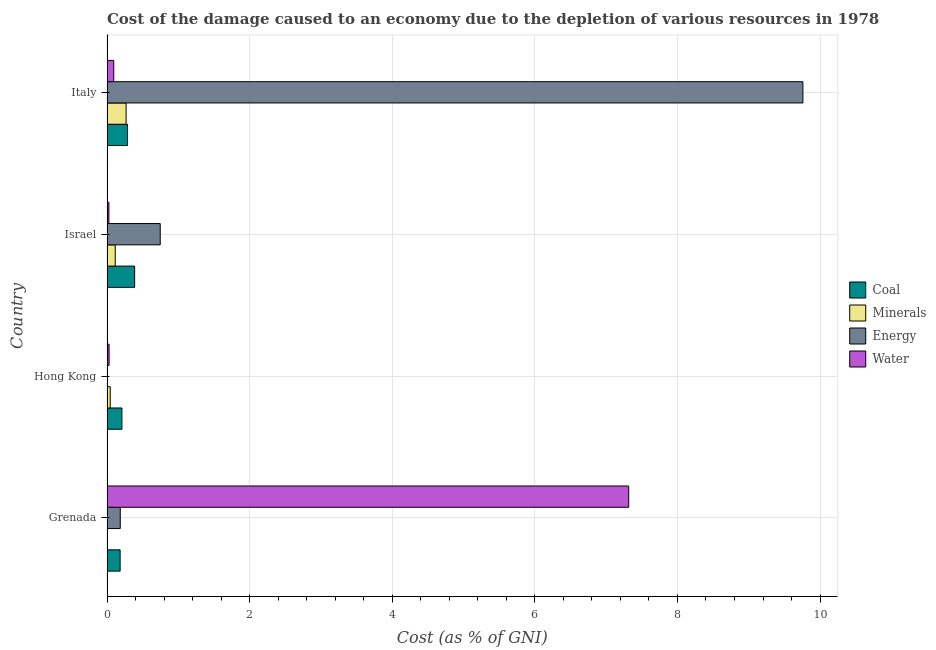Are the number of bars on each tick of the Y-axis equal?
Offer a very short reply. Yes. How many bars are there on the 1st tick from the bottom?
Provide a short and direct response. 4. What is the label of the 3rd group of bars from the top?
Make the answer very short. Hong Kong. What is the cost of damage due to depletion of energy in Israel?
Your response must be concise. 0.75. Across all countries, what is the maximum cost of damage due to depletion of water?
Ensure brevity in your answer.  7.32. Across all countries, what is the minimum cost of damage due to depletion of coal?
Your response must be concise. 0.18. In which country was the cost of damage due to depletion of water maximum?
Your answer should be compact. Grenada. What is the total cost of damage due to depletion of water in the graph?
Ensure brevity in your answer.  7.47. What is the difference between the cost of damage due to depletion of coal in Grenada and that in Italy?
Keep it short and to the point. -0.1. What is the difference between the cost of damage due to depletion of energy in Hong Kong and the cost of damage due to depletion of water in Israel?
Make the answer very short. -0.02. What is the average cost of damage due to depletion of coal per country?
Keep it short and to the point. 0.27. What is the difference between the cost of damage due to depletion of water and cost of damage due to depletion of energy in Israel?
Your answer should be compact. -0.72. In how many countries, is the cost of damage due to depletion of coal greater than 8 %?
Your answer should be very brief. 0. What is the ratio of the cost of damage due to depletion of coal in Hong Kong to that in Israel?
Give a very brief answer. 0.54. Is the difference between the cost of damage due to depletion of energy in Grenada and Hong Kong greater than the difference between the cost of damage due to depletion of minerals in Grenada and Hong Kong?
Offer a very short reply. Yes. What is the difference between the highest and the second highest cost of damage due to depletion of minerals?
Give a very brief answer. 0.15. What does the 4th bar from the top in Hong Kong represents?
Your answer should be compact. Coal. What does the 1st bar from the bottom in Israel represents?
Provide a succinct answer. Coal. Are all the bars in the graph horizontal?
Your answer should be very brief. Yes. What is the difference between two consecutive major ticks on the X-axis?
Offer a terse response. 2. Are the values on the major ticks of X-axis written in scientific E-notation?
Provide a short and direct response. No. How many legend labels are there?
Make the answer very short. 4. What is the title of the graph?
Offer a very short reply. Cost of the damage caused to an economy due to the depletion of various resources in 1978 . Does "Salary of employees" appear as one of the legend labels in the graph?
Make the answer very short. No. What is the label or title of the X-axis?
Your answer should be compact. Cost (as % of GNI). What is the label or title of the Y-axis?
Ensure brevity in your answer.  Country. What is the Cost (as % of GNI) in Coal in Grenada?
Your answer should be compact. 0.18. What is the Cost (as % of GNI) in Minerals in Grenada?
Offer a terse response. 0. What is the Cost (as % of GNI) in Energy in Grenada?
Offer a very short reply. 0.19. What is the Cost (as % of GNI) of Water in Grenada?
Your answer should be very brief. 7.32. What is the Cost (as % of GNI) in Coal in Hong Kong?
Offer a very short reply. 0.21. What is the Cost (as % of GNI) in Minerals in Hong Kong?
Offer a terse response. 0.05. What is the Cost (as % of GNI) in Energy in Hong Kong?
Keep it short and to the point. 0. What is the Cost (as % of GNI) in Water in Hong Kong?
Give a very brief answer. 0.03. What is the Cost (as % of GNI) of Coal in Israel?
Your response must be concise. 0.39. What is the Cost (as % of GNI) of Minerals in Israel?
Your response must be concise. 0.12. What is the Cost (as % of GNI) in Energy in Israel?
Your answer should be very brief. 0.75. What is the Cost (as % of GNI) in Water in Israel?
Your response must be concise. 0.03. What is the Cost (as % of GNI) in Coal in Italy?
Provide a succinct answer. 0.29. What is the Cost (as % of GNI) of Minerals in Italy?
Your answer should be compact. 0.27. What is the Cost (as % of GNI) in Energy in Italy?
Provide a succinct answer. 9.76. What is the Cost (as % of GNI) in Water in Italy?
Your response must be concise. 0.09. Across all countries, what is the maximum Cost (as % of GNI) in Coal?
Your answer should be very brief. 0.39. Across all countries, what is the maximum Cost (as % of GNI) of Minerals?
Your answer should be very brief. 0.27. Across all countries, what is the maximum Cost (as % of GNI) of Energy?
Your answer should be very brief. 9.76. Across all countries, what is the maximum Cost (as % of GNI) of Water?
Your response must be concise. 7.32. Across all countries, what is the minimum Cost (as % of GNI) in Coal?
Make the answer very short. 0.18. Across all countries, what is the minimum Cost (as % of GNI) of Minerals?
Ensure brevity in your answer.  0. Across all countries, what is the minimum Cost (as % of GNI) in Energy?
Your response must be concise. 0. Across all countries, what is the minimum Cost (as % of GNI) in Water?
Provide a short and direct response. 0.03. What is the total Cost (as % of GNI) in Coal in the graph?
Offer a terse response. 1.07. What is the total Cost (as % of GNI) of Minerals in the graph?
Offer a terse response. 0.43. What is the total Cost (as % of GNI) of Energy in the graph?
Provide a succinct answer. 10.69. What is the total Cost (as % of GNI) of Water in the graph?
Provide a succinct answer. 7.47. What is the difference between the Cost (as % of GNI) in Coal in Grenada and that in Hong Kong?
Keep it short and to the point. -0.03. What is the difference between the Cost (as % of GNI) of Minerals in Grenada and that in Hong Kong?
Your answer should be compact. -0.04. What is the difference between the Cost (as % of GNI) in Energy in Grenada and that in Hong Kong?
Give a very brief answer. 0.18. What is the difference between the Cost (as % of GNI) of Water in Grenada and that in Hong Kong?
Make the answer very short. 7.29. What is the difference between the Cost (as % of GNI) in Coal in Grenada and that in Israel?
Offer a terse response. -0.2. What is the difference between the Cost (as % of GNI) in Minerals in Grenada and that in Israel?
Offer a very short reply. -0.11. What is the difference between the Cost (as % of GNI) of Energy in Grenada and that in Israel?
Offer a terse response. -0.56. What is the difference between the Cost (as % of GNI) of Water in Grenada and that in Israel?
Your answer should be compact. 7.29. What is the difference between the Cost (as % of GNI) in Coal in Grenada and that in Italy?
Offer a terse response. -0.1. What is the difference between the Cost (as % of GNI) of Minerals in Grenada and that in Italy?
Offer a very short reply. -0.27. What is the difference between the Cost (as % of GNI) of Energy in Grenada and that in Italy?
Offer a terse response. -9.57. What is the difference between the Cost (as % of GNI) in Water in Grenada and that in Italy?
Provide a succinct answer. 7.22. What is the difference between the Cost (as % of GNI) of Coal in Hong Kong and that in Israel?
Provide a succinct answer. -0.18. What is the difference between the Cost (as % of GNI) in Minerals in Hong Kong and that in Israel?
Your answer should be very brief. -0.07. What is the difference between the Cost (as % of GNI) in Energy in Hong Kong and that in Israel?
Offer a terse response. -0.74. What is the difference between the Cost (as % of GNI) in Water in Hong Kong and that in Israel?
Make the answer very short. 0. What is the difference between the Cost (as % of GNI) of Coal in Hong Kong and that in Italy?
Make the answer very short. -0.08. What is the difference between the Cost (as % of GNI) in Minerals in Hong Kong and that in Italy?
Keep it short and to the point. -0.22. What is the difference between the Cost (as % of GNI) of Energy in Hong Kong and that in Italy?
Give a very brief answer. -9.76. What is the difference between the Cost (as % of GNI) of Water in Hong Kong and that in Italy?
Offer a terse response. -0.07. What is the difference between the Cost (as % of GNI) in Coal in Israel and that in Italy?
Your answer should be very brief. 0.1. What is the difference between the Cost (as % of GNI) in Minerals in Israel and that in Italy?
Your answer should be compact. -0.15. What is the difference between the Cost (as % of GNI) in Energy in Israel and that in Italy?
Ensure brevity in your answer.  -9.01. What is the difference between the Cost (as % of GNI) in Water in Israel and that in Italy?
Offer a very short reply. -0.07. What is the difference between the Cost (as % of GNI) in Coal in Grenada and the Cost (as % of GNI) in Minerals in Hong Kong?
Provide a short and direct response. 0.14. What is the difference between the Cost (as % of GNI) in Coal in Grenada and the Cost (as % of GNI) in Energy in Hong Kong?
Provide a succinct answer. 0.18. What is the difference between the Cost (as % of GNI) in Coal in Grenada and the Cost (as % of GNI) in Water in Hong Kong?
Your response must be concise. 0.15. What is the difference between the Cost (as % of GNI) of Minerals in Grenada and the Cost (as % of GNI) of Energy in Hong Kong?
Provide a succinct answer. -0. What is the difference between the Cost (as % of GNI) of Minerals in Grenada and the Cost (as % of GNI) of Water in Hong Kong?
Ensure brevity in your answer.  -0.03. What is the difference between the Cost (as % of GNI) in Energy in Grenada and the Cost (as % of GNI) in Water in Hong Kong?
Provide a short and direct response. 0.16. What is the difference between the Cost (as % of GNI) of Coal in Grenada and the Cost (as % of GNI) of Minerals in Israel?
Your answer should be compact. 0.07. What is the difference between the Cost (as % of GNI) in Coal in Grenada and the Cost (as % of GNI) in Energy in Israel?
Your response must be concise. -0.56. What is the difference between the Cost (as % of GNI) in Coal in Grenada and the Cost (as % of GNI) in Water in Israel?
Make the answer very short. 0.16. What is the difference between the Cost (as % of GNI) in Minerals in Grenada and the Cost (as % of GNI) in Energy in Israel?
Offer a very short reply. -0.75. What is the difference between the Cost (as % of GNI) of Minerals in Grenada and the Cost (as % of GNI) of Water in Israel?
Offer a terse response. -0.03. What is the difference between the Cost (as % of GNI) in Energy in Grenada and the Cost (as % of GNI) in Water in Israel?
Provide a short and direct response. 0.16. What is the difference between the Cost (as % of GNI) of Coal in Grenada and the Cost (as % of GNI) of Minerals in Italy?
Your answer should be compact. -0.08. What is the difference between the Cost (as % of GNI) of Coal in Grenada and the Cost (as % of GNI) of Energy in Italy?
Keep it short and to the point. -9.58. What is the difference between the Cost (as % of GNI) in Coal in Grenada and the Cost (as % of GNI) in Water in Italy?
Your response must be concise. 0.09. What is the difference between the Cost (as % of GNI) in Minerals in Grenada and the Cost (as % of GNI) in Energy in Italy?
Ensure brevity in your answer.  -9.76. What is the difference between the Cost (as % of GNI) in Minerals in Grenada and the Cost (as % of GNI) in Water in Italy?
Make the answer very short. -0.09. What is the difference between the Cost (as % of GNI) of Energy in Grenada and the Cost (as % of GNI) of Water in Italy?
Make the answer very short. 0.09. What is the difference between the Cost (as % of GNI) in Coal in Hong Kong and the Cost (as % of GNI) in Minerals in Israel?
Ensure brevity in your answer.  0.09. What is the difference between the Cost (as % of GNI) in Coal in Hong Kong and the Cost (as % of GNI) in Energy in Israel?
Your answer should be very brief. -0.54. What is the difference between the Cost (as % of GNI) in Coal in Hong Kong and the Cost (as % of GNI) in Water in Israel?
Offer a terse response. 0.18. What is the difference between the Cost (as % of GNI) in Minerals in Hong Kong and the Cost (as % of GNI) in Energy in Israel?
Your answer should be compact. -0.7. What is the difference between the Cost (as % of GNI) of Minerals in Hong Kong and the Cost (as % of GNI) of Water in Israel?
Ensure brevity in your answer.  0.02. What is the difference between the Cost (as % of GNI) in Energy in Hong Kong and the Cost (as % of GNI) in Water in Israel?
Ensure brevity in your answer.  -0.02. What is the difference between the Cost (as % of GNI) of Coal in Hong Kong and the Cost (as % of GNI) of Minerals in Italy?
Provide a succinct answer. -0.06. What is the difference between the Cost (as % of GNI) of Coal in Hong Kong and the Cost (as % of GNI) of Energy in Italy?
Your answer should be compact. -9.55. What is the difference between the Cost (as % of GNI) in Coal in Hong Kong and the Cost (as % of GNI) in Water in Italy?
Provide a succinct answer. 0.11. What is the difference between the Cost (as % of GNI) in Minerals in Hong Kong and the Cost (as % of GNI) in Energy in Italy?
Your response must be concise. -9.71. What is the difference between the Cost (as % of GNI) of Minerals in Hong Kong and the Cost (as % of GNI) of Water in Italy?
Your answer should be compact. -0.05. What is the difference between the Cost (as % of GNI) in Energy in Hong Kong and the Cost (as % of GNI) in Water in Italy?
Your response must be concise. -0.09. What is the difference between the Cost (as % of GNI) of Coal in Israel and the Cost (as % of GNI) of Minerals in Italy?
Provide a succinct answer. 0.12. What is the difference between the Cost (as % of GNI) of Coal in Israel and the Cost (as % of GNI) of Energy in Italy?
Make the answer very short. -9.37. What is the difference between the Cost (as % of GNI) in Coal in Israel and the Cost (as % of GNI) in Water in Italy?
Ensure brevity in your answer.  0.29. What is the difference between the Cost (as % of GNI) of Minerals in Israel and the Cost (as % of GNI) of Energy in Italy?
Provide a short and direct response. -9.64. What is the difference between the Cost (as % of GNI) of Minerals in Israel and the Cost (as % of GNI) of Water in Italy?
Keep it short and to the point. 0.02. What is the difference between the Cost (as % of GNI) in Energy in Israel and the Cost (as % of GNI) in Water in Italy?
Provide a succinct answer. 0.65. What is the average Cost (as % of GNI) of Coal per country?
Make the answer very short. 0.27. What is the average Cost (as % of GNI) in Minerals per country?
Your answer should be very brief. 0.11. What is the average Cost (as % of GNI) in Energy per country?
Give a very brief answer. 2.67. What is the average Cost (as % of GNI) in Water per country?
Your response must be concise. 1.87. What is the difference between the Cost (as % of GNI) in Coal and Cost (as % of GNI) in Minerals in Grenada?
Offer a very short reply. 0.18. What is the difference between the Cost (as % of GNI) in Coal and Cost (as % of GNI) in Energy in Grenada?
Offer a very short reply. -0. What is the difference between the Cost (as % of GNI) in Coal and Cost (as % of GNI) in Water in Grenada?
Offer a very short reply. -7.13. What is the difference between the Cost (as % of GNI) of Minerals and Cost (as % of GNI) of Energy in Grenada?
Offer a terse response. -0.19. What is the difference between the Cost (as % of GNI) in Minerals and Cost (as % of GNI) in Water in Grenada?
Your answer should be compact. -7.32. What is the difference between the Cost (as % of GNI) in Energy and Cost (as % of GNI) in Water in Grenada?
Make the answer very short. -7.13. What is the difference between the Cost (as % of GNI) in Coal and Cost (as % of GNI) in Minerals in Hong Kong?
Your response must be concise. 0.16. What is the difference between the Cost (as % of GNI) of Coal and Cost (as % of GNI) of Energy in Hong Kong?
Provide a succinct answer. 0.21. What is the difference between the Cost (as % of GNI) in Coal and Cost (as % of GNI) in Water in Hong Kong?
Make the answer very short. 0.18. What is the difference between the Cost (as % of GNI) in Minerals and Cost (as % of GNI) in Energy in Hong Kong?
Keep it short and to the point. 0.04. What is the difference between the Cost (as % of GNI) in Minerals and Cost (as % of GNI) in Water in Hong Kong?
Your answer should be compact. 0.02. What is the difference between the Cost (as % of GNI) of Energy and Cost (as % of GNI) of Water in Hong Kong?
Offer a terse response. -0.03. What is the difference between the Cost (as % of GNI) of Coal and Cost (as % of GNI) of Minerals in Israel?
Your answer should be compact. 0.27. What is the difference between the Cost (as % of GNI) of Coal and Cost (as % of GNI) of Energy in Israel?
Keep it short and to the point. -0.36. What is the difference between the Cost (as % of GNI) of Coal and Cost (as % of GNI) of Water in Israel?
Ensure brevity in your answer.  0.36. What is the difference between the Cost (as % of GNI) of Minerals and Cost (as % of GNI) of Energy in Israel?
Keep it short and to the point. -0.63. What is the difference between the Cost (as % of GNI) of Minerals and Cost (as % of GNI) of Water in Israel?
Your answer should be compact. 0.09. What is the difference between the Cost (as % of GNI) of Energy and Cost (as % of GNI) of Water in Israel?
Make the answer very short. 0.72. What is the difference between the Cost (as % of GNI) in Coal and Cost (as % of GNI) in Minerals in Italy?
Your answer should be compact. 0.02. What is the difference between the Cost (as % of GNI) in Coal and Cost (as % of GNI) in Energy in Italy?
Give a very brief answer. -9.47. What is the difference between the Cost (as % of GNI) of Coal and Cost (as % of GNI) of Water in Italy?
Offer a very short reply. 0.19. What is the difference between the Cost (as % of GNI) of Minerals and Cost (as % of GNI) of Energy in Italy?
Your answer should be compact. -9.49. What is the difference between the Cost (as % of GNI) in Minerals and Cost (as % of GNI) in Water in Italy?
Ensure brevity in your answer.  0.17. What is the difference between the Cost (as % of GNI) of Energy and Cost (as % of GNI) of Water in Italy?
Provide a succinct answer. 9.67. What is the ratio of the Cost (as % of GNI) in Coal in Grenada to that in Hong Kong?
Your answer should be very brief. 0.88. What is the ratio of the Cost (as % of GNI) in Minerals in Grenada to that in Hong Kong?
Ensure brevity in your answer.  0.02. What is the ratio of the Cost (as % of GNI) of Energy in Grenada to that in Hong Kong?
Make the answer very short. 102.57. What is the ratio of the Cost (as % of GNI) of Water in Grenada to that in Hong Kong?
Your answer should be compact. 251.6. What is the ratio of the Cost (as % of GNI) of Coal in Grenada to that in Israel?
Your answer should be very brief. 0.47. What is the ratio of the Cost (as % of GNI) of Minerals in Grenada to that in Israel?
Provide a succinct answer. 0.01. What is the ratio of the Cost (as % of GNI) of Energy in Grenada to that in Israel?
Your answer should be compact. 0.25. What is the ratio of the Cost (as % of GNI) of Water in Grenada to that in Israel?
Your answer should be compact. 277.35. What is the ratio of the Cost (as % of GNI) in Coal in Grenada to that in Italy?
Your answer should be very brief. 0.64. What is the ratio of the Cost (as % of GNI) in Minerals in Grenada to that in Italy?
Ensure brevity in your answer.  0. What is the ratio of the Cost (as % of GNI) in Energy in Grenada to that in Italy?
Ensure brevity in your answer.  0.02. What is the ratio of the Cost (as % of GNI) in Water in Grenada to that in Italy?
Ensure brevity in your answer.  77.53. What is the ratio of the Cost (as % of GNI) of Coal in Hong Kong to that in Israel?
Offer a terse response. 0.54. What is the ratio of the Cost (as % of GNI) of Minerals in Hong Kong to that in Israel?
Give a very brief answer. 0.39. What is the ratio of the Cost (as % of GNI) in Energy in Hong Kong to that in Israel?
Your answer should be compact. 0. What is the ratio of the Cost (as % of GNI) of Water in Hong Kong to that in Israel?
Your response must be concise. 1.1. What is the ratio of the Cost (as % of GNI) of Coal in Hong Kong to that in Italy?
Ensure brevity in your answer.  0.73. What is the ratio of the Cost (as % of GNI) in Minerals in Hong Kong to that in Italy?
Give a very brief answer. 0.17. What is the ratio of the Cost (as % of GNI) in Water in Hong Kong to that in Italy?
Give a very brief answer. 0.31. What is the ratio of the Cost (as % of GNI) in Coal in Israel to that in Italy?
Your answer should be compact. 1.35. What is the ratio of the Cost (as % of GNI) in Minerals in Israel to that in Italy?
Your answer should be very brief. 0.43. What is the ratio of the Cost (as % of GNI) of Energy in Israel to that in Italy?
Make the answer very short. 0.08. What is the ratio of the Cost (as % of GNI) of Water in Israel to that in Italy?
Give a very brief answer. 0.28. What is the difference between the highest and the second highest Cost (as % of GNI) of Coal?
Make the answer very short. 0.1. What is the difference between the highest and the second highest Cost (as % of GNI) of Minerals?
Provide a short and direct response. 0.15. What is the difference between the highest and the second highest Cost (as % of GNI) in Energy?
Offer a very short reply. 9.01. What is the difference between the highest and the second highest Cost (as % of GNI) of Water?
Ensure brevity in your answer.  7.22. What is the difference between the highest and the lowest Cost (as % of GNI) in Coal?
Your response must be concise. 0.2. What is the difference between the highest and the lowest Cost (as % of GNI) of Minerals?
Give a very brief answer. 0.27. What is the difference between the highest and the lowest Cost (as % of GNI) in Energy?
Your response must be concise. 9.76. What is the difference between the highest and the lowest Cost (as % of GNI) in Water?
Give a very brief answer. 7.29. 